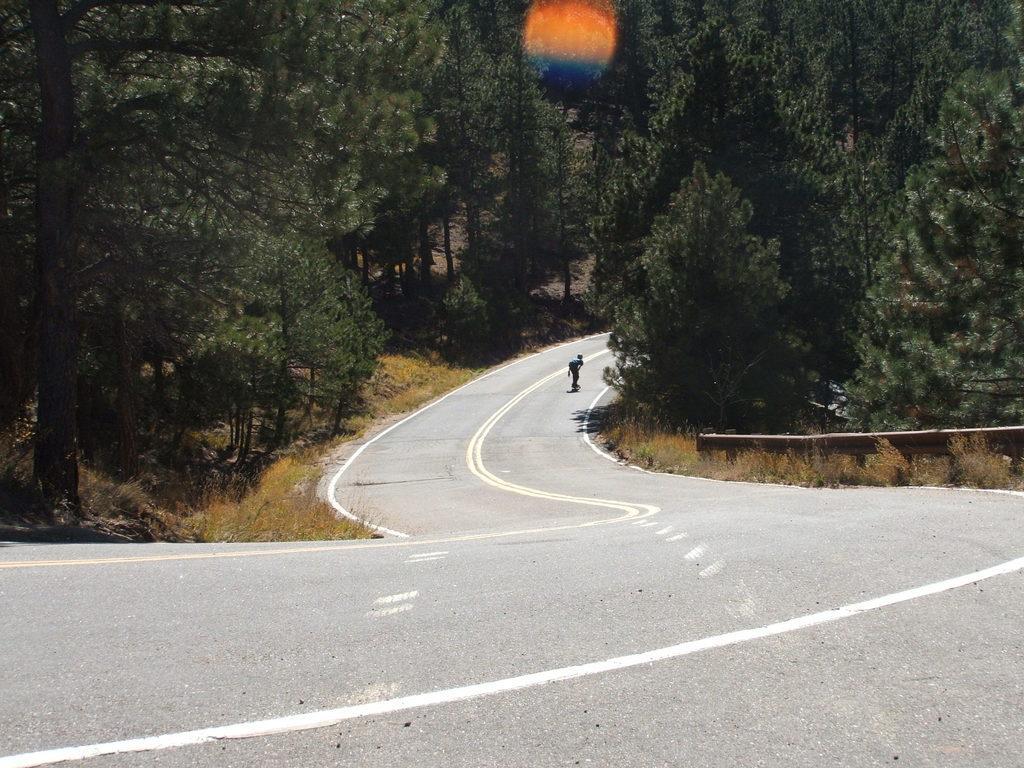Can you describe this image briefly? In this picture we can see the view of the road in the middle of the image. On both the side there are some trees. In the background there is a boy doing skating on the road. 